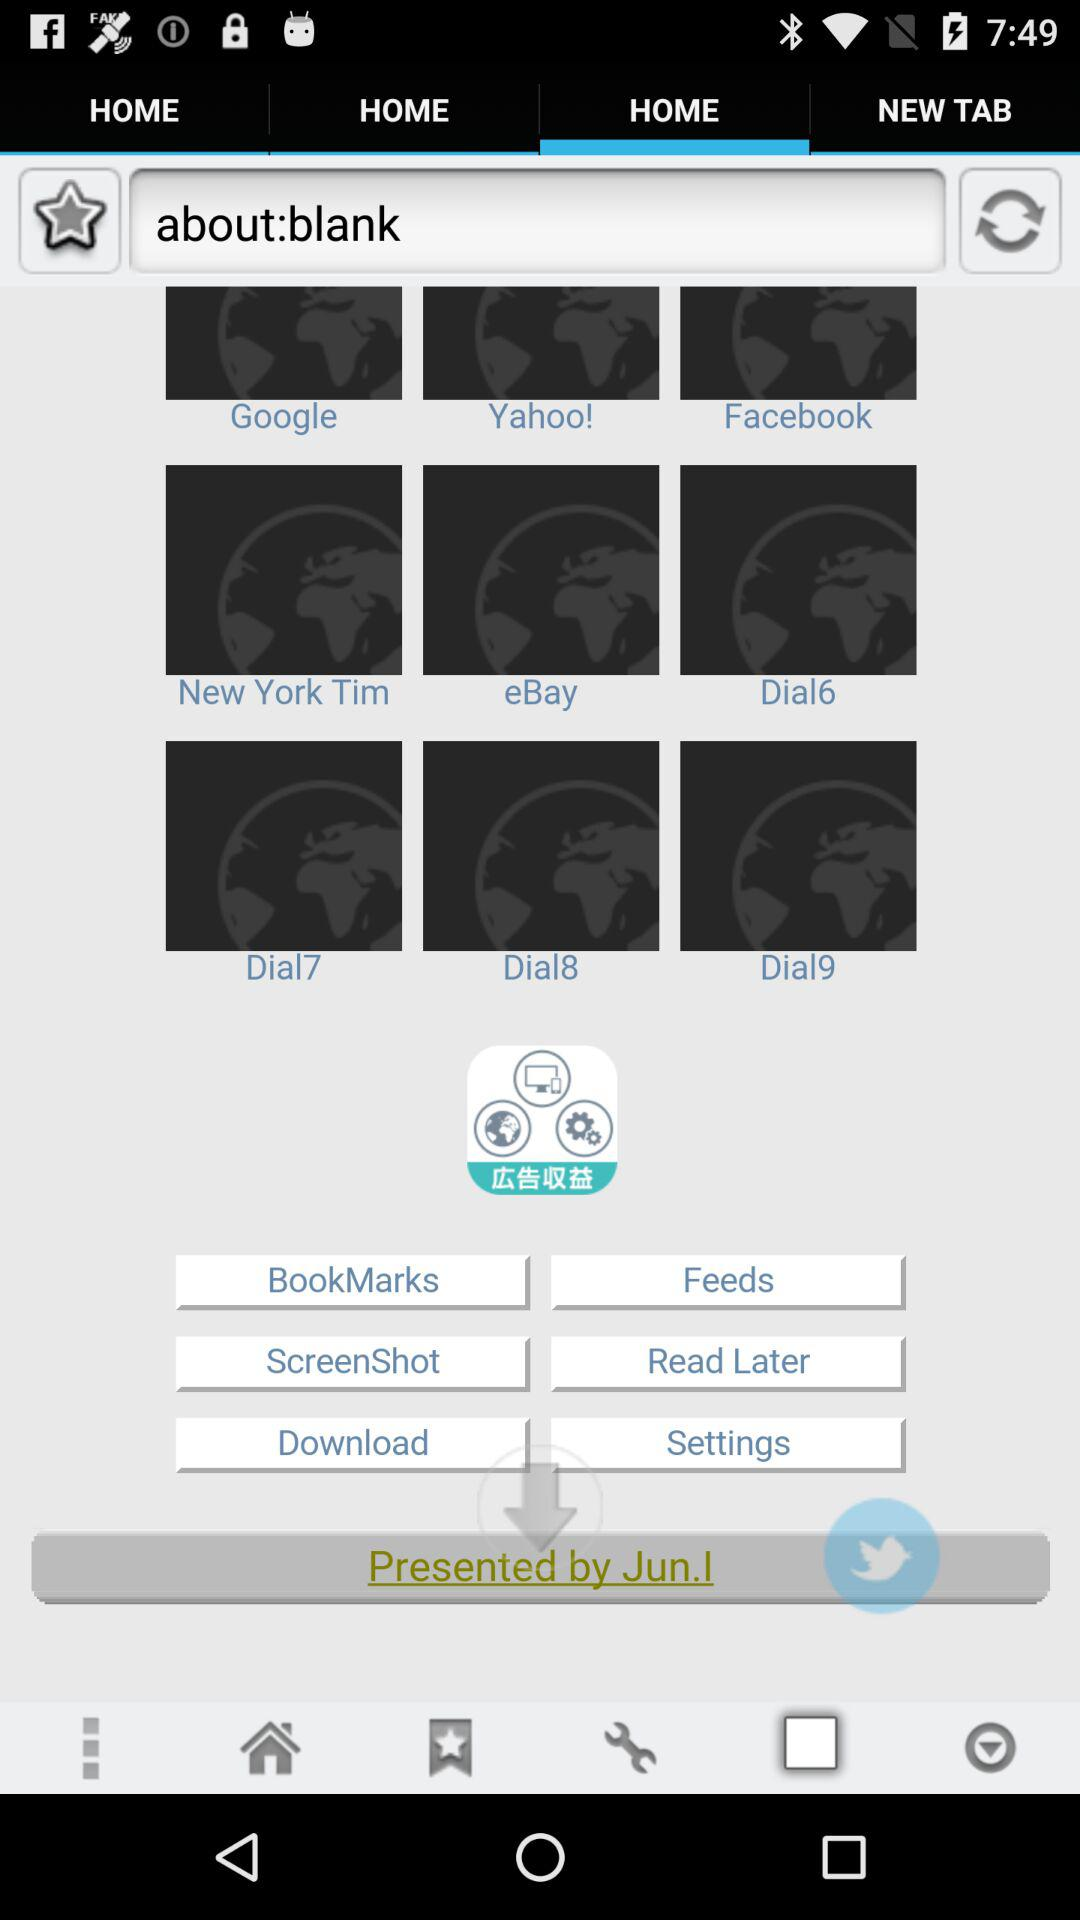Which tab is selected? The selected tab is "HOME". 